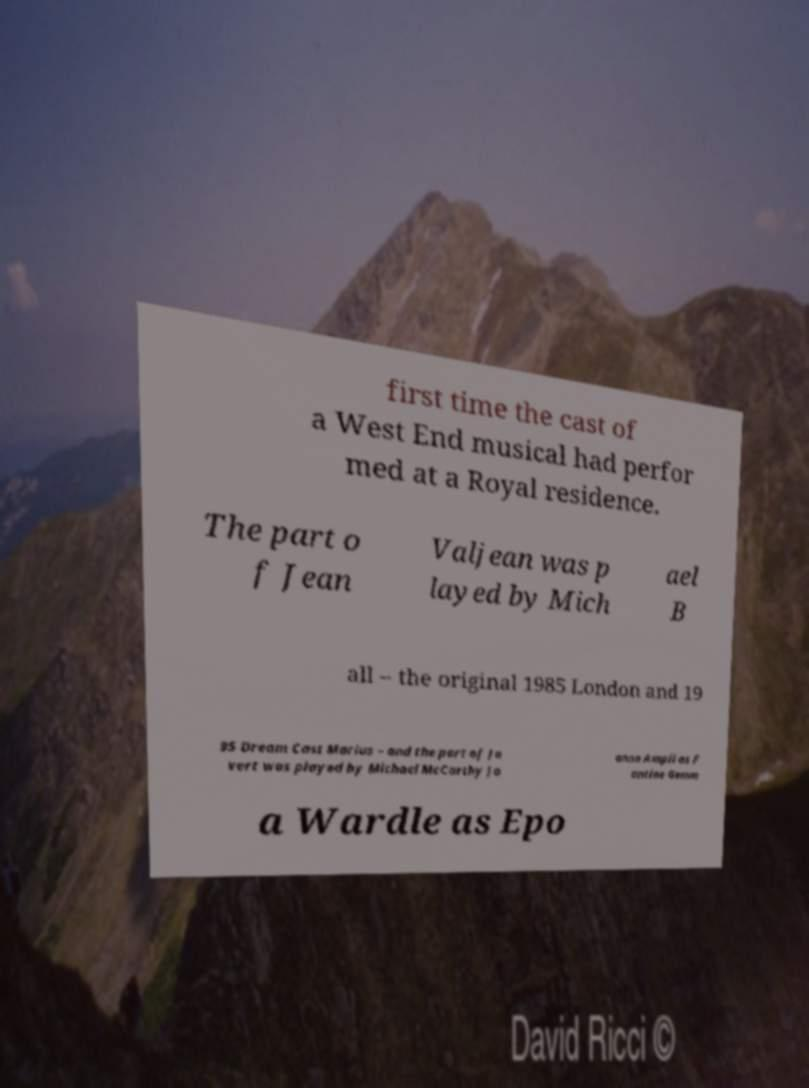Can you read and provide the text displayed in the image?This photo seems to have some interesting text. Can you extract and type it out for me? first time the cast of a West End musical had perfor med at a Royal residence. The part o f Jean Valjean was p layed by Mich ael B all – the original 1985 London and 19 95 Dream Cast Marius – and the part of Ja vert was played by Michael McCarthy Jo anna Ampil as F antine Gemm a Wardle as Epo 